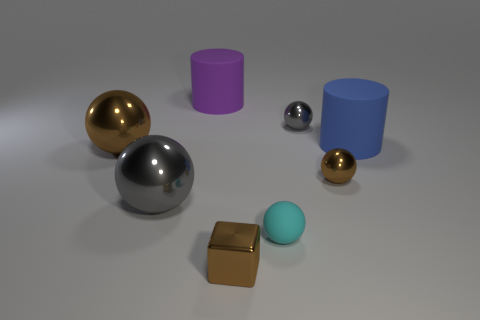Subtract 2 balls. How many balls are left? 3 Subtract all brown spheres. How many spheres are left? 3 Subtract all tiny brown balls. How many balls are left? 4 Add 1 big blue shiny things. How many objects exist? 9 Subtract all cyan spheres. Subtract all purple cubes. How many spheres are left? 4 Subtract all blocks. How many objects are left? 7 Add 6 big brown metallic objects. How many big brown metallic objects are left? 7 Add 6 large purple matte cylinders. How many large purple matte cylinders exist? 7 Subtract 0 brown cylinders. How many objects are left? 8 Subtract all big gray metallic things. Subtract all large brown objects. How many objects are left? 6 